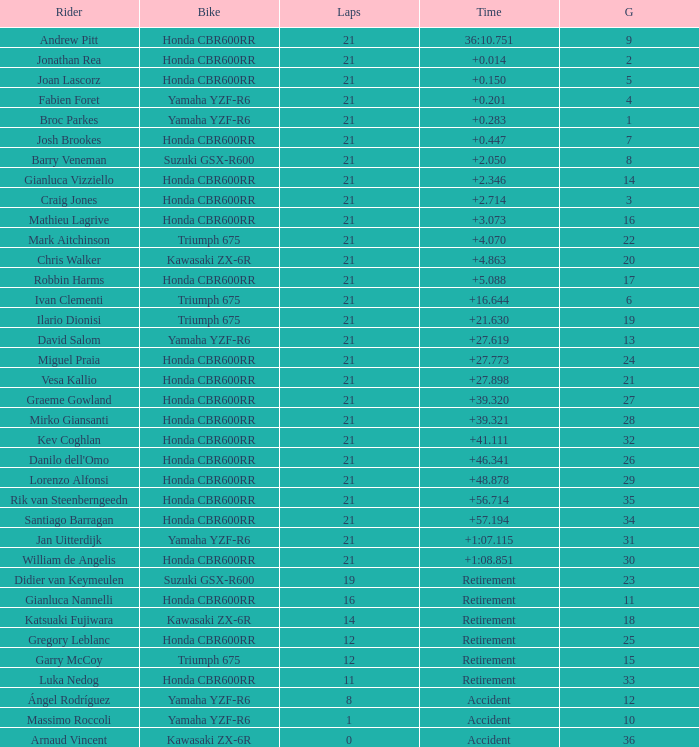What is the highest number of laps completed by ilario dionisi? 21.0. 